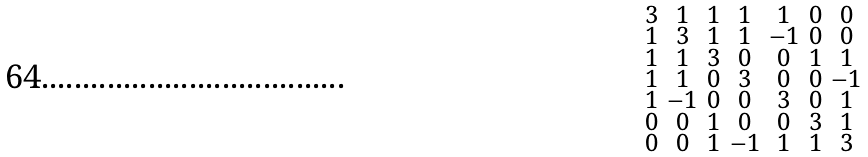Convert formula to latex. <formula><loc_0><loc_0><loc_500><loc_500>\begin{smallmatrix} 3 & 1 & 1 & 1 & 1 & 0 & 0 \\ 1 & 3 & 1 & 1 & - 1 & 0 & 0 \\ 1 & 1 & 3 & 0 & 0 & 1 & 1 \\ 1 & 1 & 0 & 3 & 0 & 0 & - 1 \\ 1 & - 1 & 0 & 0 & 3 & 0 & 1 \\ 0 & 0 & 1 & 0 & 0 & 3 & 1 \\ 0 & 0 & 1 & - 1 & 1 & 1 & 3 \end{smallmatrix}</formula> 